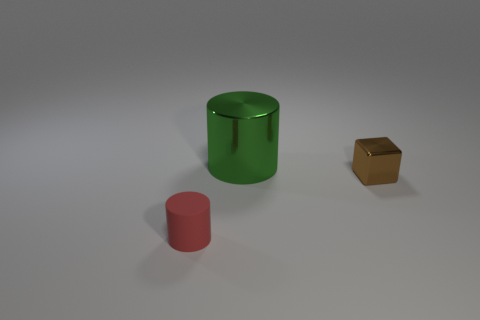Are there any other things that are the same size as the green metallic cylinder?
Give a very brief answer. No. There is a object that is in front of the metal cylinder and on the left side of the tiny brown cube; what is its color?
Ensure brevity in your answer.  Red. What shape is the rubber object that is the same size as the metal cube?
Make the answer very short. Cylinder. Are there any tiny metallic cylinders that have the same color as the matte object?
Your answer should be very brief. No. Are there an equal number of small red rubber cylinders right of the green metallic cylinder and big brown cylinders?
Your answer should be very brief. Yes. Does the big thing have the same color as the metal cube?
Offer a terse response. No. What is the size of the thing that is both to the right of the small matte cylinder and on the left side of the tiny brown metallic block?
Your answer should be compact. Large. There is a tiny block that is made of the same material as the big object; what is its color?
Offer a terse response. Brown. How many blocks have the same material as the large cylinder?
Provide a succinct answer. 1. Are there an equal number of brown metallic cubes that are in front of the red rubber object and brown metal things left of the brown block?
Keep it short and to the point. Yes. 